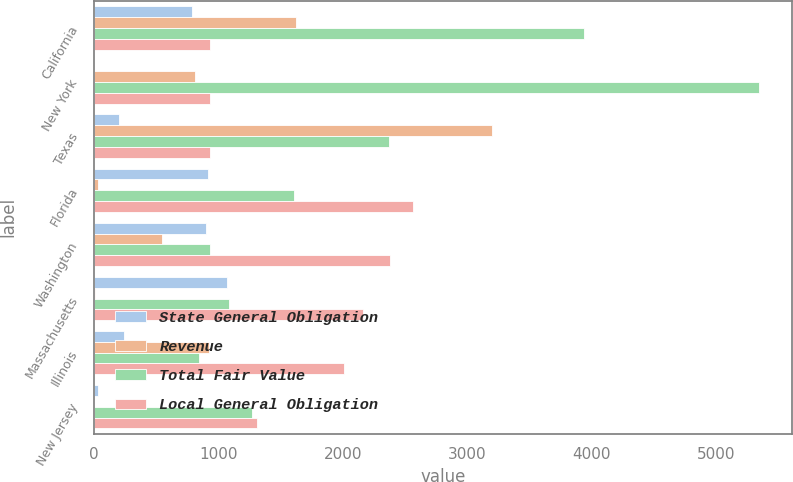Convert chart to OTSL. <chart><loc_0><loc_0><loc_500><loc_500><stacked_bar_chart><ecel><fcel>California<fcel>New York<fcel>Texas<fcel>Florida<fcel>Washington<fcel>Massachusetts<fcel>Illinois<fcel>New Jersey<nl><fcel>State General Obligation<fcel>788<fcel>3<fcel>201<fcel>915<fcel>900<fcel>1068<fcel>241<fcel>38<nl><fcel>Revenue<fcel>1628<fcel>813<fcel>3199<fcel>38<fcel>547<fcel>10<fcel>926<fcel>3<nl><fcel>Total Fair Value<fcel>3937<fcel>5346<fcel>2371<fcel>1610<fcel>937<fcel>1088<fcel>845<fcel>1272<nl><fcel>Local General Obligation<fcel>937<fcel>937<fcel>937<fcel>2563<fcel>2384<fcel>2166<fcel>2012<fcel>1313<nl></chart> 